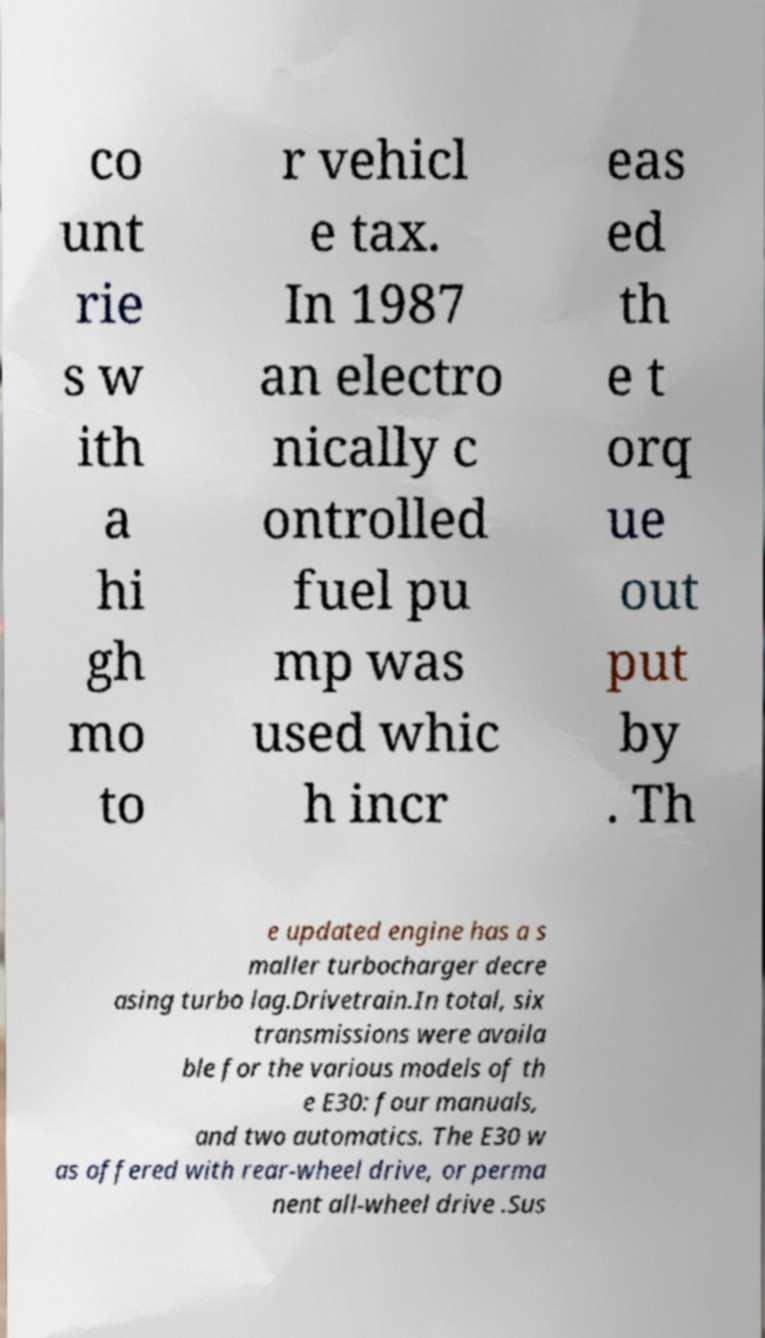Can you accurately transcribe the text from the provided image for me? co unt rie s w ith a hi gh mo to r vehicl e tax. In 1987 an electro nically c ontrolled fuel pu mp was used whic h incr eas ed th e t orq ue out put by . Th e updated engine has a s maller turbocharger decre asing turbo lag.Drivetrain.In total, six transmissions were availa ble for the various models of th e E30: four manuals, and two automatics. The E30 w as offered with rear-wheel drive, or perma nent all-wheel drive .Sus 